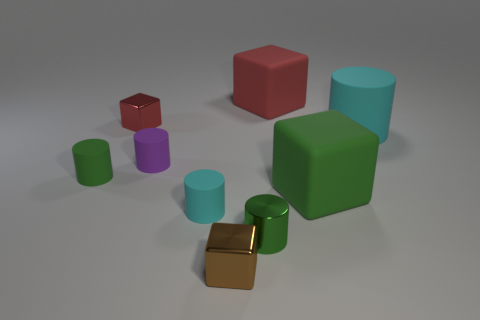Is the number of small purple things on the right side of the big cyan object greater than the number of large cyan things in front of the brown shiny block?
Provide a succinct answer. No. What number of other objects are there of the same size as the red rubber thing?
Offer a very short reply. 2. There is a tiny green matte thing; does it have the same shape as the cyan matte thing behind the tiny purple object?
Give a very brief answer. Yes. How many rubber objects are small things or small red cubes?
Your response must be concise. 3. Are there any rubber cylinders of the same color as the shiny cylinder?
Give a very brief answer. Yes. Are there any small red objects?
Your answer should be compact. Yes. Is the shape of the small red metal thing the same as the purple object?
Offer a terse response. No. How many tiny things are gray rubber balls or brown things?
Ensure brevity in your answer.  1. What color is the big matte cylinder?
Offer a terse response. Cyan. The cyan rubber object behind the object that is to the left of the small red metallic object is what shape?
Give a very brief answer. Cylinder. 